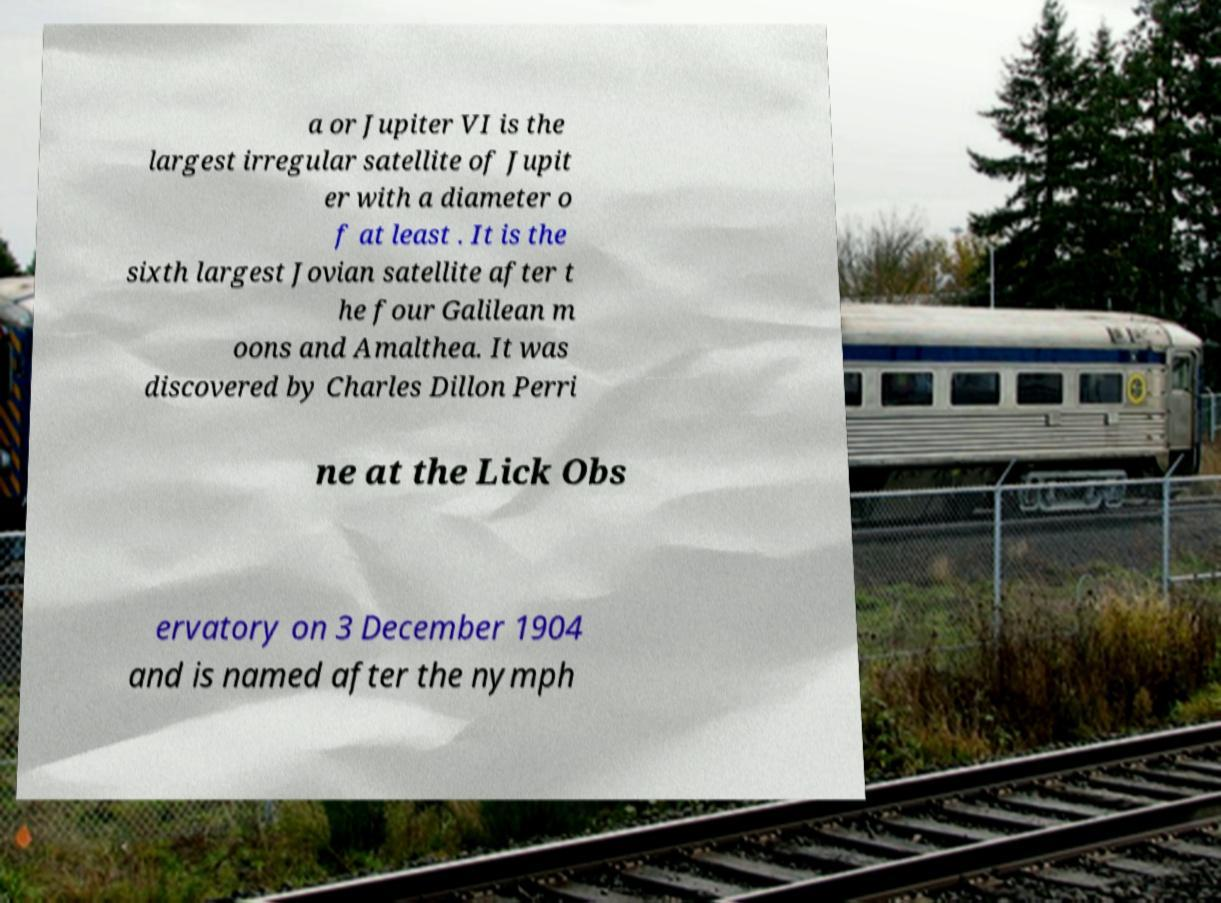Can you read and provide the text displayed in the image?This photo seems to have some interesting text. Can you extract and type it out for me? a or Jupiter VI is the largest irregular satellite of Jupit er with a diameter o f at least . It is the sixth largest Jovian satellite after t he four Galilean m oons and Amalthea. It was discovered by Charles Dillon Perri ne at the Lick Obs ervatory on 3 December 1904 and is named after the nymph 